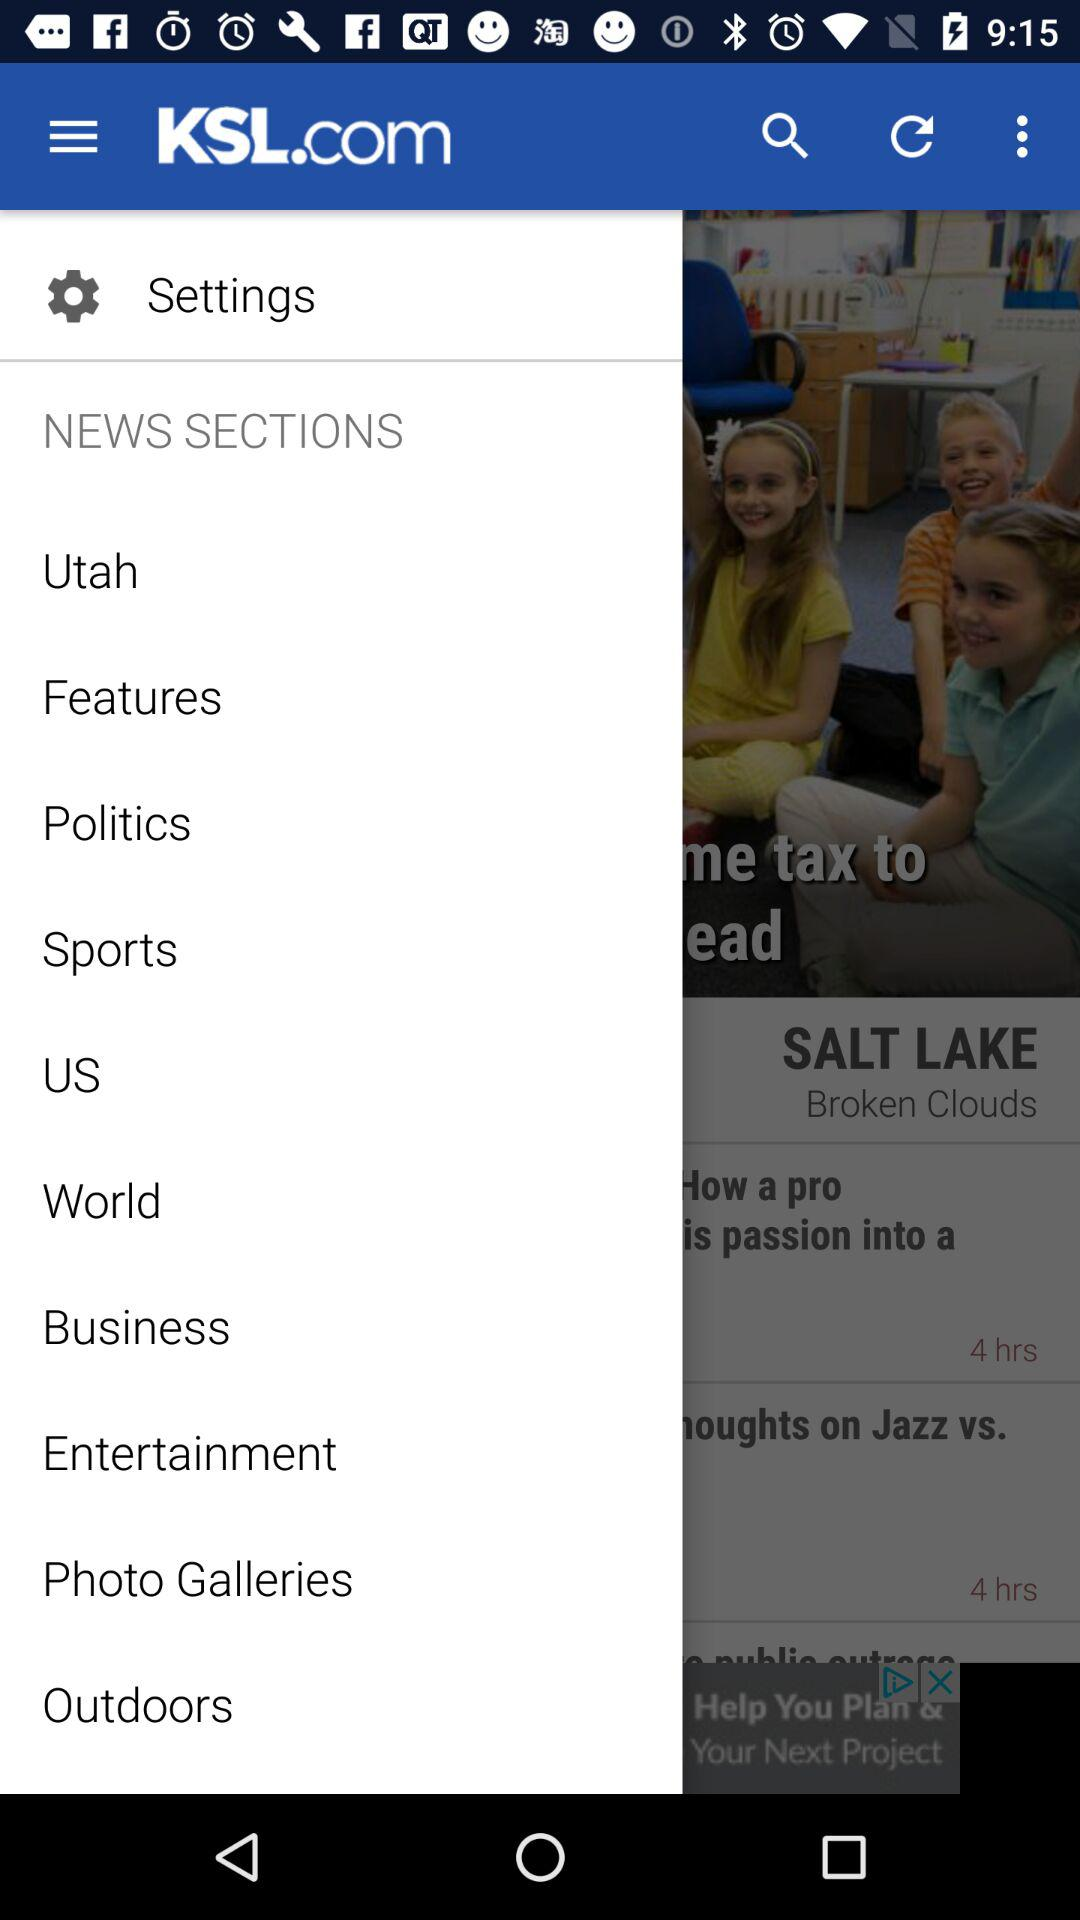What is the name of the application? The name of the application is "KSL.com". 